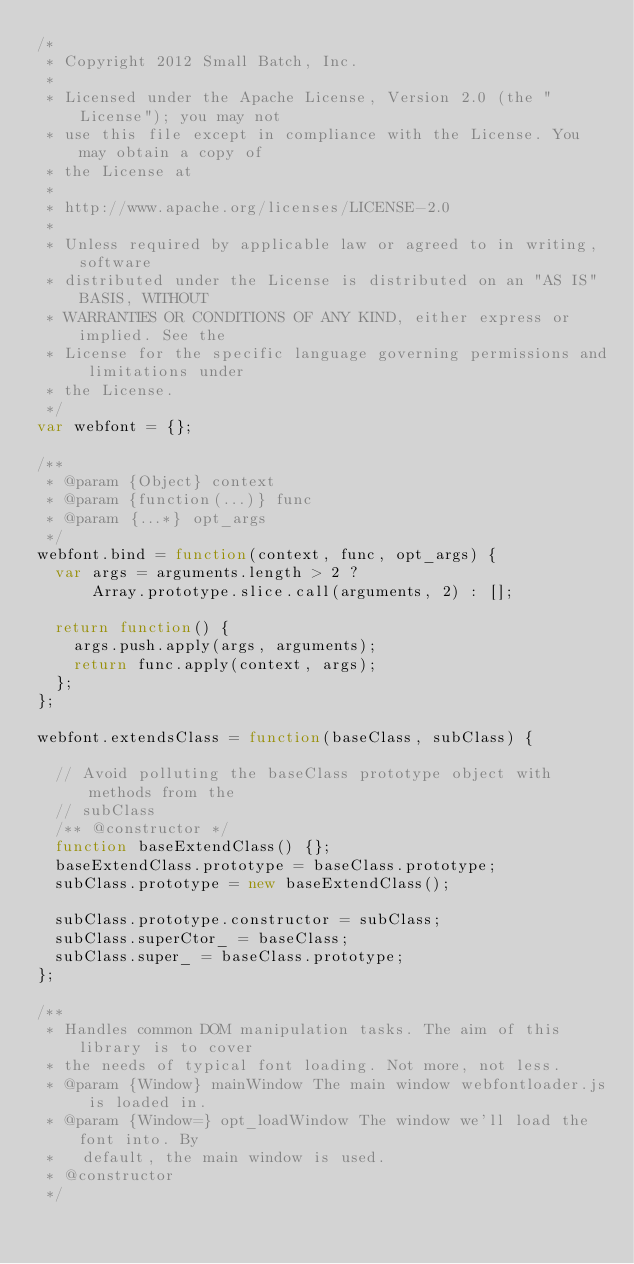<code> <loc_0><loc_0><loc_500><loc_500><_JavaScript_>/*
 * Copyright 2012 Small Batch, Inc.
 *
 * Licensed under the Apache License, Version 2.0 (the "License"); you may not
 * use this file except in compliance with the License. You may obtain a copy of
 * the License at
 *
 * http://www.apache.org/licenses/LICENSE-2.0
 *
 * Unless required by applicable law or agreed to in writing, software
 * distributed under the License is distributed on an "AS IS" BASIS, WITHOUT
 * WARRANTIES OR CONDITIONS OF ANY KIND, either express or implied. See the
 * License for the specific language governing permissions and limitations under
 * the License.
 */
var webfont = {};

/**
 * @param {Object} context
 * @param {function(...)} func
 * @param {...*} opt_args
 */
webfont.bind = function(context, func, opt_args) {
  var args = arguments.length > 2 ?
      Array.prototype.slice.call(arguments, 2) : [];

  return function() {
    args.push.apply(args, arguments);
    return func.apply(context, args);
  };
};

webfont.extendsClass = function(baseClass, subClass) {

  // Avoid polluting the baseClass prototype object with methods from the
  // subClass
  /** @constructor */
  function baseExtendClass() {};
  baseExtendClass.prototype = baseClass.prototype;
  subClass.prototype = new baseExtendClass();

  subClass.prototype.constructor = subClass;
  subClass.superCtor_ = baseClass;
  subClass.super_ = baseClass.prototype;
};

/**
 * Handles common DOM manipulation tasks. The aim of this library is to cover
 * the needs of typical font loading. Not more, not less.
 * @param {Window} mainWindow The main window webfontloader.js is loaded in.
 * @param {Window=} opt_loadWindow The window we'll load the font into. By
 *   default, the main window is used.
 * @constructor
 */</code> 